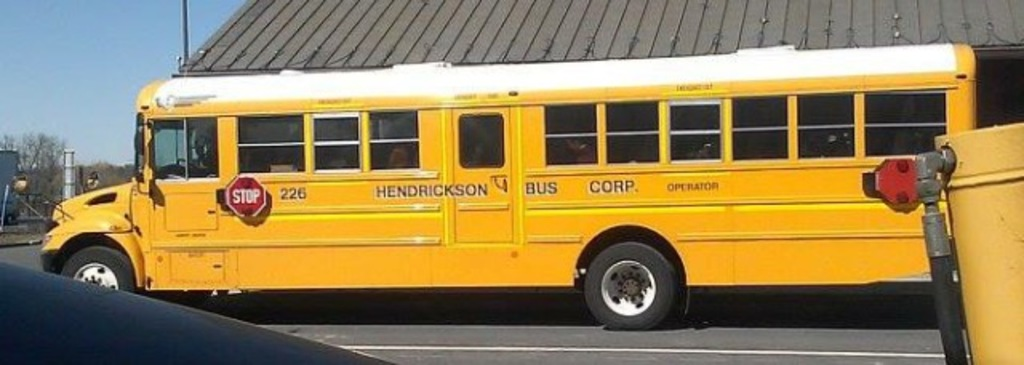What might be the daily routine of this bus? This bus likely starts its day early in the morning, making several rounds to pick up students and ensure they get to school on time. After school hours, it probably runs a similar route to take students back home, and then it's parked until the next school day. 